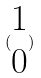<formula> <loc_0><loc_0><loc_500><loc_500>( \begin{matrix} 1 \\ 0 \end{matrix} )</formula> 